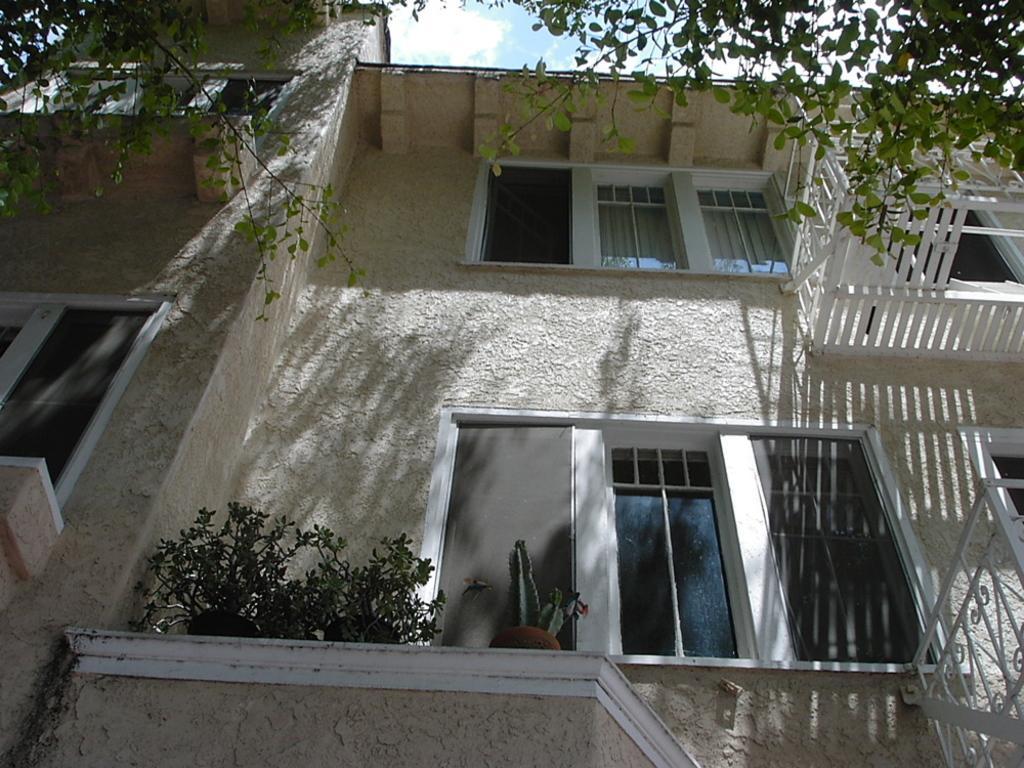Could you give a brief overview of what you see in this image? In this picture we can see a building, few trees, plants and metal rods, at the top of the image we can see clouds. 